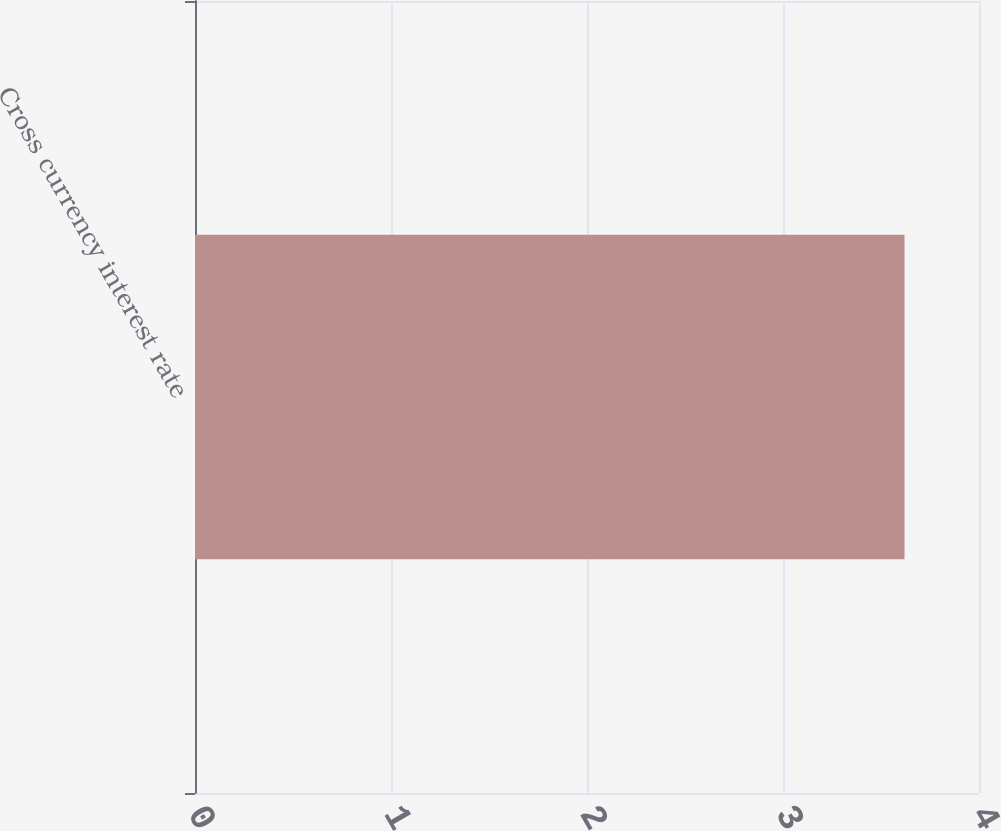<chart> <loc_0><loc_0><loc_500><loc_500><bar_chart><fcel>Cross currency interest rate<nl><fcel>3.62<nl></chart> 